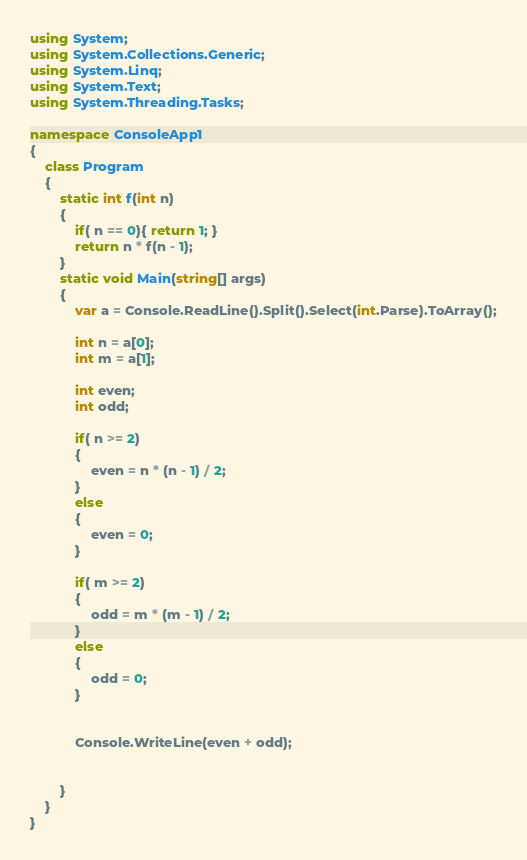Convert code to text. <code><loc_0><loc_0><loc_500><loc_500><_C#_>using System;
using System.Collections.Generic;
using System.Linq;
using System.Text;
using System.Threading.Tasks;

namespace ConsoleApp1
{
    class Program
    {
        static int f(int n)
        {
            if( n == 0){ return 1; }
            return n * f(n - 1);
        }
        static void Main(string[] args)
        {
            var a = Console.ReadLine().Split().Select(int.Parse).ToArray();

            int n = a[0];
            int m = a[1];

            int even;
            int odd;

            if( n >= 2)
            {
                even = n * (n - 1) / 2;
            }
            else
            {
                even = 0;
            }

            if( m >= 2)
            {
                odd = m * (m - 1) / 2;
            }
            else
            {
                odd = 0;
            }


            Console.WriteLine(even + odd);


        }
    }
}
</code> 